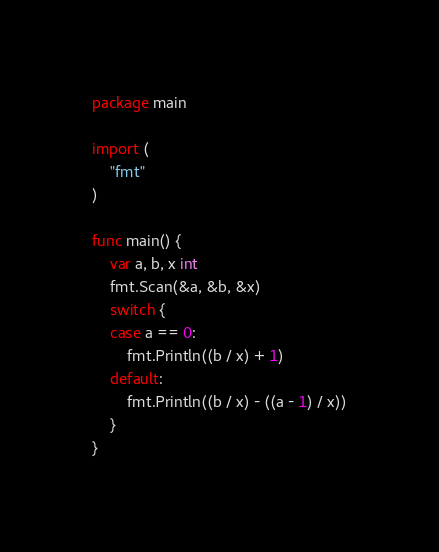Convert code to text. <code><loc_0><loc_0><loc_500><loc_500><_Go_>package main

import (
	"fmt"
)

func main() {
	var a, b, x int
	fmt.Scan(&a, &b, &x)
	switch {
	case a == 0:
		fmt.Println((b / x) + 1)
	default:
		fmt.Println((b / x) - ((a - 1) / x))
	}
}
</code> 